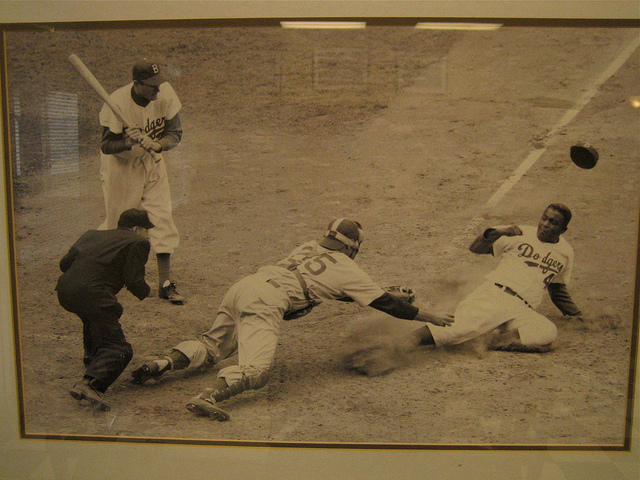Identify the text contained in this image. 25 Do dgey 4 dger 